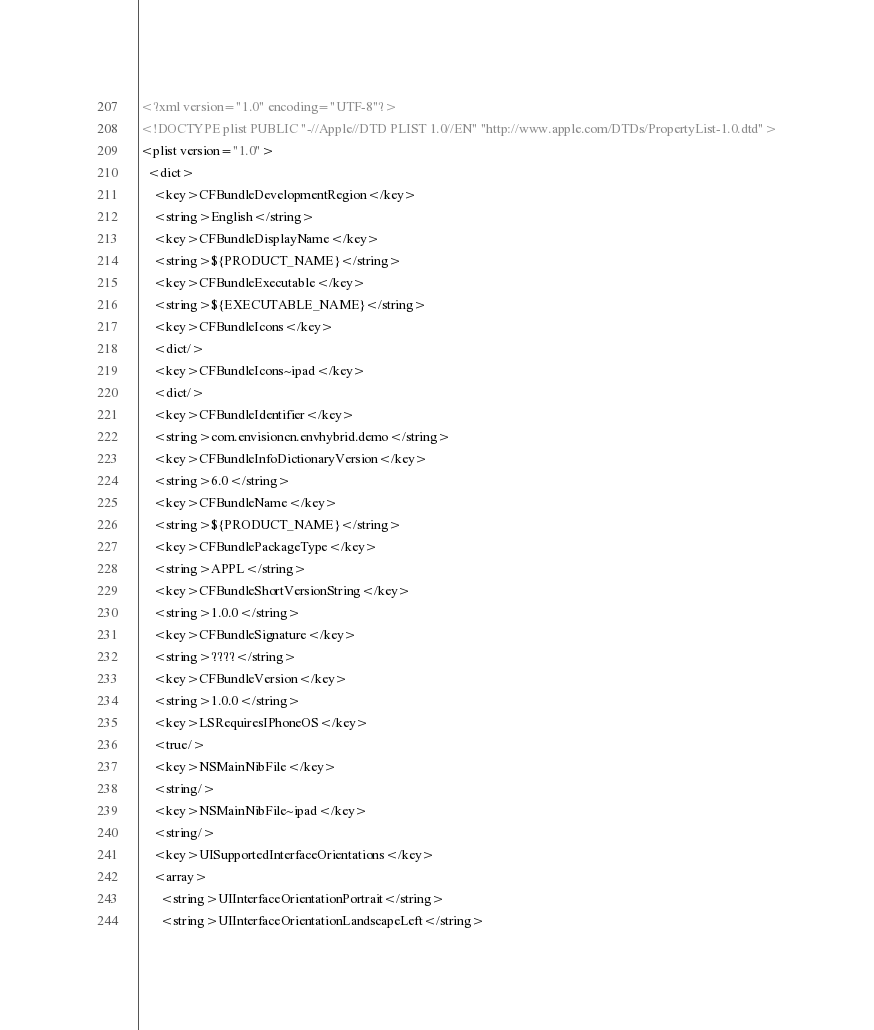Convert code to text. <code><loc_0><loc_0><loc_500><loc_500><_XML_><?xml version="1.0" encoding="UTF-8"?>
<!DOCTYPE plist PUBLIC "-//Apple//DTD PLIST 1.0//EN" "http://www.apple.com/DTDs/PropertyList-1.0.dtd">
<plist version="1.0">
  <dict>
    <key>CFBundleDevelopmentRegion</key>
    <string>English</string>
    <key>CFBundleDisplayName</key>
    <string>${PRODUCT_NAME}</string>
    <key>CFBundleExecutable</key>
    <string>${EXECUTABLE_NAME}</string>
    <key>CFBundleIcons</key>
    <dict/>
    <key>CFBundleIcons~ipad</key>
    <dict/>
    <key>CFBundleIdentifier</key>
    <string>com.envisioncn.envhybrid.demo</string>
    <key>CFBundleInfoDictionaryVersion</key>
    <string>6.0</string>
    <key>CFBundleName</key>
    <string>${PRODUCT_NAME}</string>
    <key>CFBundlePackageType</key>
    <string>APPL</string>
    <key>CFBundleShortVersionString</key>
    <string>1.0.0</string>
    <key>CFBundleSignature</key>
    <string>????</string>
    <key>CFBundleVersion</key>
    <string>1.0.0</string>
    <key>LSRequiresIPhoneOS</key>
    <true/>
    <key>NSMainNibFile</key>
    <string/>
    <key>NSMainNibFile~ipad</key>
    <string/>
    <key>UISupportedInterfaceOrientations</key>
    <array>
      <string>UIInterfaceOrientationPortrait</string>
      <string>UIInterfaceOrientationLandscapeLeft</string></code> 